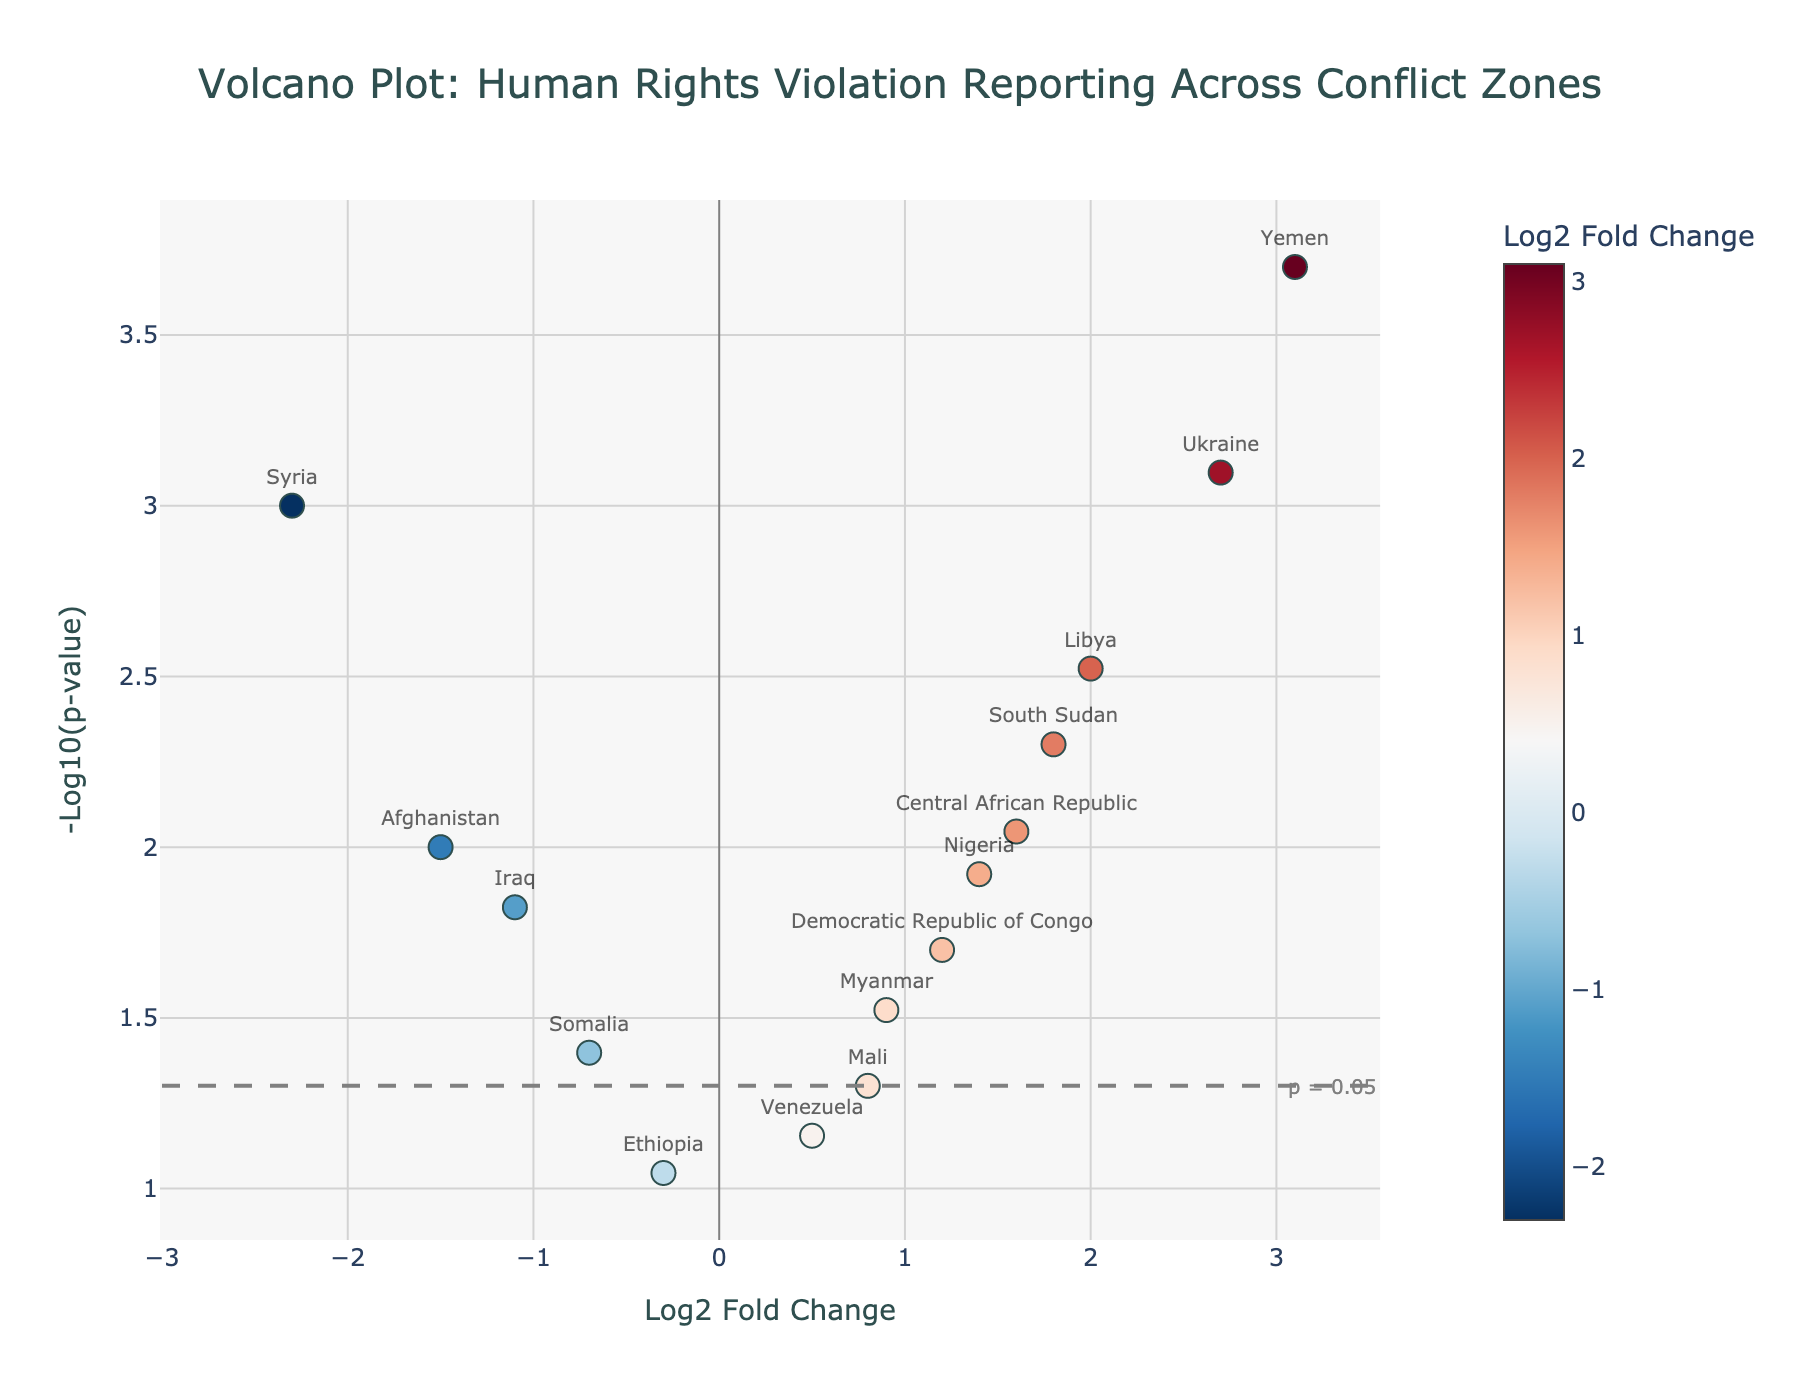What is the title of the figure? The title is displayed at the top of the figure and generally summarizes the content.
Answer: Volcano Plot: Human Rights Violation Reporting Across Conflict Zones How many conflict zones have a negative Log2 Fold Change value? By counting the number of markers located left of the zero-line on the x-axis, we determine the count of conflict zones with negative Log2 Fold Change.
Answer: 6 Which conflict zone has the highest Log2 Fold Change? Identify the marker furthest right on the x-axis, its label will indicate the conflict zone with the highest Log2 Fold Change.
Answer: Yemen What is the p-value threshold line's y-axis value, and what does it indicate? The p-value threshold line is horizontal, marked by the annotation "p = 0.05". Its y-axis value corresponds to -log10(0.05).
Answer: 1.3 How many conflict zones have a Log2 Fold Change greater than 2 and a p-value less than 0.01? Identify markers to the right of the 2 on the x-axis and above the y-axis value corresponding to -log10(0.01). Count these markers to determine the total.
Answer: 3 Which conflict zone has the smallest p-value? Locate the label of the marker positioned highest on the y-axis; this signifies the smallest p-value.
Answer: Yemen Compare the Log2 Fold Change values of Syria and Libya. Which one is more negative? Find Syria and Libya on the plot, then compare their x-axis positions. The more negative Log2 Fold Change lies further to the left.
Answer: Syria Is there any conflict zone near the significance threshold with a log2 fold change between -1 and 1? Look at the data points around the horizontal threshold line (y-axis ~1.3) and check if any points have Log2 Fold Change values between -1 and 1.
Answer: Yes, Venezuela and Ethiopia What is the difference in -log10(p-value) between South Sudan and Afghanistan? Identify the y-axis values for South Sudan and Afghanistan, then calculate the difference between these values.
Answer: 0.7 Which conflict zones have significant p-values (less than 0.05) but relatively low log2 fold change (less than 1)? Identify markers below 1 on the x-axis and above the threshold line on the y-axis annotation, then check which ones have significant p-values.
Answer: Afghanistan, Iraq, Myanmar, Somalia, Democratic Republic of Congo 